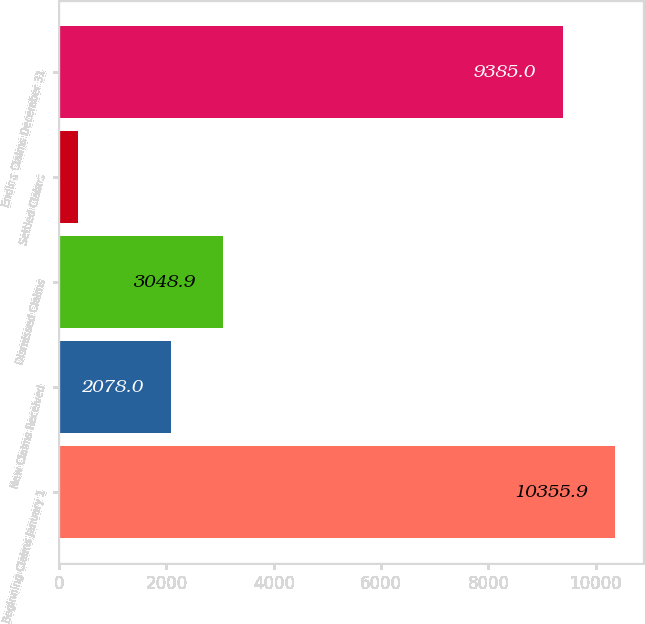Convert chart to OTSL. <chart><loc_0><loc_0><loc_500><loc_500><bar_chart><fcel>Beginning Claims January 1<fcel>New Claims Received<fcel>Dismissed Claims<fcel>Settled Claims<fcel>Ending Claims December 31<nl><fcel>10355.9<fcel>2078<fcel>3048.9<fcel>352<fcel>9385<nl></chart> 